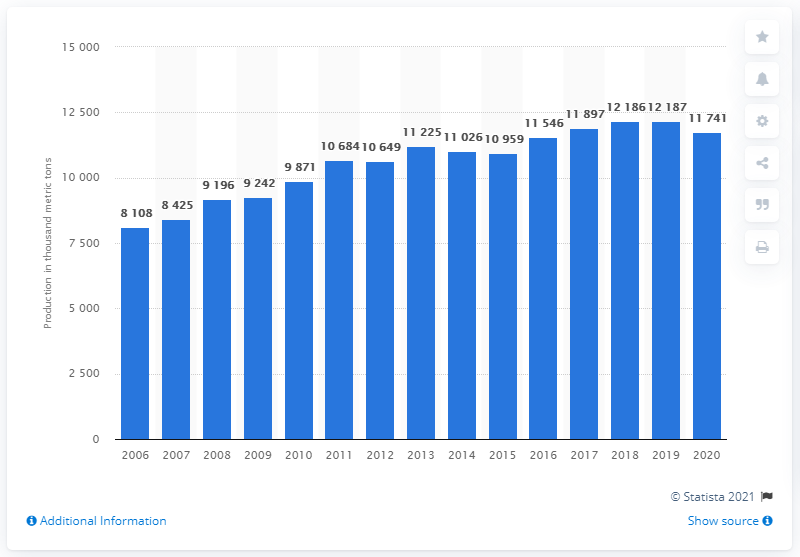Mention a couple of crucial points in this snapshot. The production of lead declined for the first time in the year 2015. 